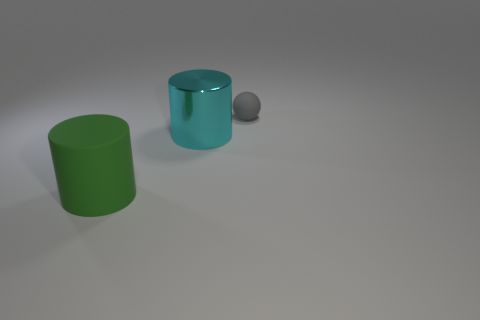Do the tiny gray ball and the cyan thing have the same material?
Offer a terse response. No. What is the color of the object that is both right of the big green thing and on the left side of the small object?
Make the answer very short. Cyan. Is the color of the thing that is to the right of the metal thing the same as the metal object?
Provide a succinct answer. No. What shape is the thing that is the same size as the matte cylinder?
Make the answer very short. Cylinder. What number of other things are made of the same material as the tiny gray sphere?
Offer a very short reply. 1. There is a green cylinder; is it the same size as the cylinder to the right of the big rubber thing?
Provide a short and direct response. Yes. What is the color of the large rubber cylinder?
Keep it short and to the point. Green. The large object on the left side of the big cylinder behind the rubber thing that is left of the tiny gray thing is what shape?
Make the answer very short. Cylinder. What is the cylinder behind the object in front of the large cyan cylinder made of?
Provide a succinct answer. Metal. The small gray thing that is the same material as the green cylinder is what shape?
Keep it short and to the point. Sphere. 